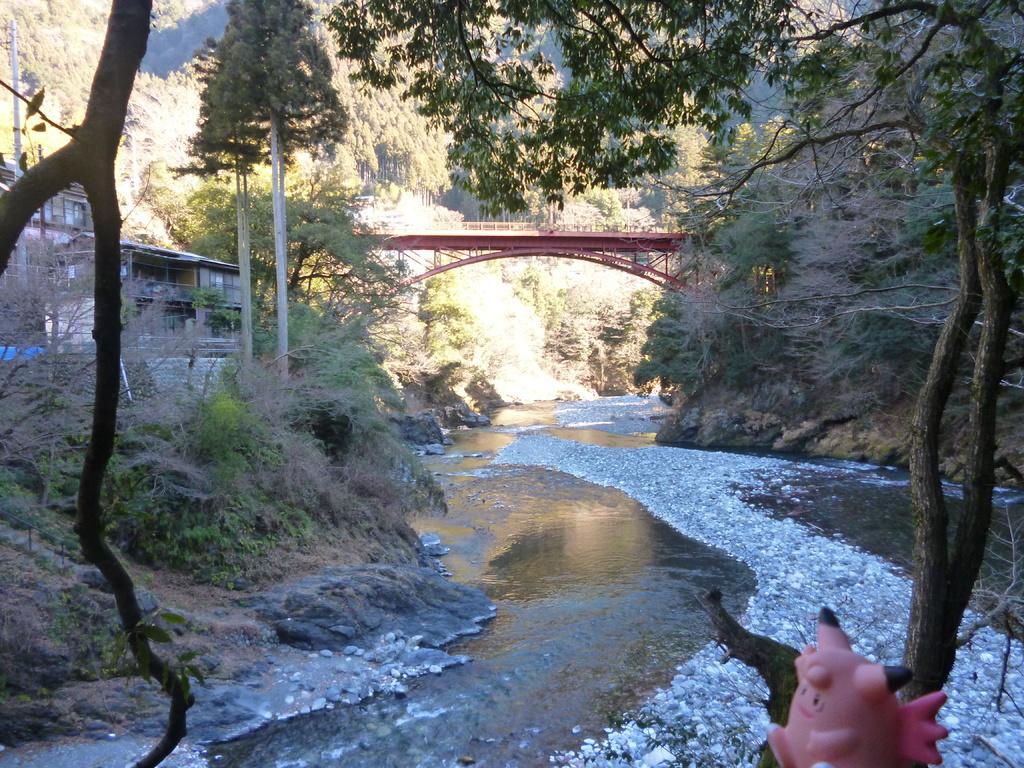How would you summarize this image in a sentence or two? In this image we can see a toy placed on the tree, water, rocks, buildings, trees, bridge and the hills in the background. 